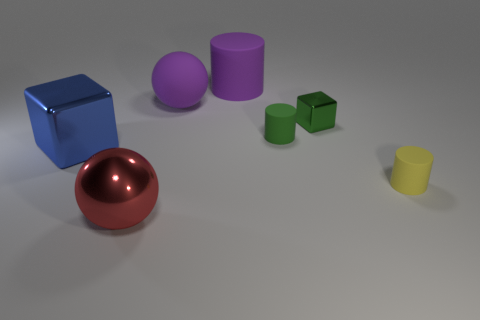What color is the metallic thing that is on the right side of the big block and behind the large red metal sphere?
Your response must be concise. Green. What number of big objects are blue shiny things or matte cylinders?
Provide a short and direct response. 2. What is the size of the other object that is the same shape as the red metal thing?
Your answer should be very brief. Large. What is the shape of the blue metallic object?
Give a very brief answer. Cube. Is the material of the large red sphere the same as the cylinder in front of the big blue block?
Your response must be concise. No. How many rubber things are either large blue objects or tiny green cylinders?
Your answer should be very brief. 1. There is a green rubber object right of the blue metal thing; what is its size?
Give a very brief answer. Small. What size is the green object that is made of the same material as the blue cube?
Provide a short and direct response. Small. What number of large objects are the same color as the large cylinder?
Offer a terse response. 1. Are there any tiny things?
Your answer should be very brief. Yes. 